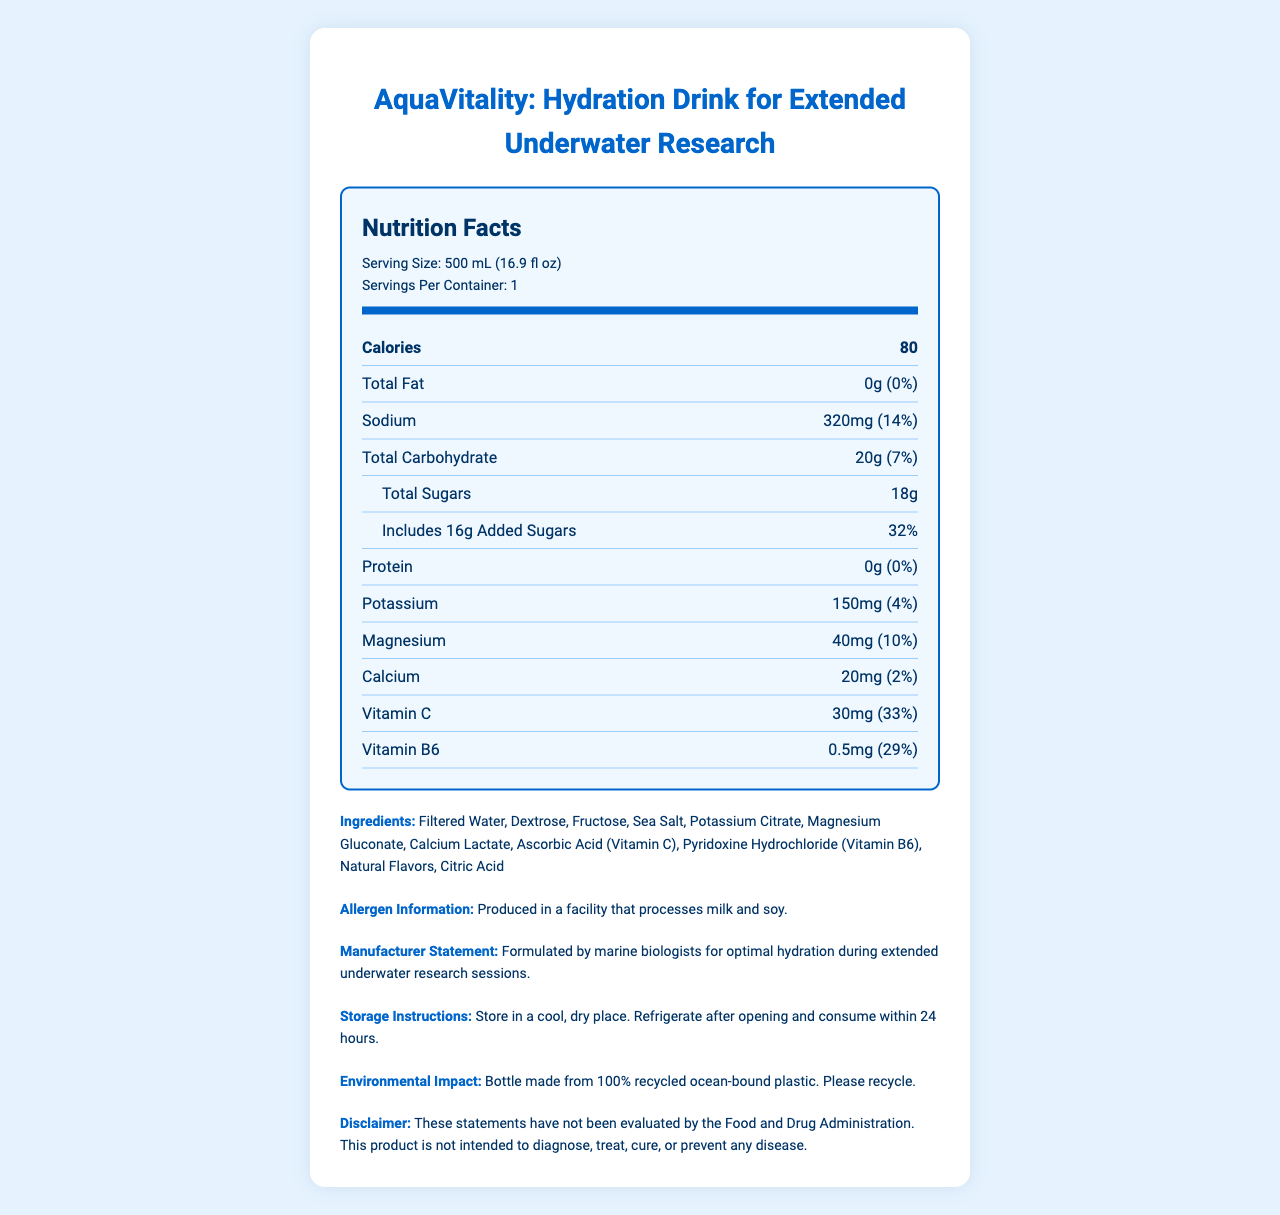what is the serving size of AquaVitality? According to the document, the serving size listed is 500 mL (16.9 fl oz).
Answer: 500 mL (16.9 fl oz) How much sodium is in one serving of AquaVitality? The document states that there are 320mg of sodium per serving.
Answer: 320mg What is the percentage of daily value for Calcium in AquaVitality? The document lists the calcium content as 20mg with a daily value of 2%.
Answer: 2% List three vitamins found in AquaVitality The document mentions Vitamin C, Vitamin B6, and Pyridoxine Hydrochloride (which is another name for Vitamin B6).
Answer: Vitamin C, Vitamin B6, Pyridoxine Hydrochloride Is there any protein in AquaVitality? The document states that there is 0g of protein in AquaVitality.
Answer: No Does AquaVitality contain any added sugars? The document mentions that there are 16g of added sugars in the total of 18g of sugars.
Answer: Yes What is the total carbohydrate content in AquaVitality? The document states that the total carbohydrate content is 20g which is 7% of the daily value.
Answer: 20g What percentage of the daily value of magnesium does AquaVitality provide? The document shows that AquaVitality contains 40mg of magnesium, which is 10% of the daily value.
Answer: 10% What is the brand statement for AquaVitality? This is directly stated in the Manufacturer Statement section of the document.
Answer: Formulated by marine biologists for optimal hydration during extended underwater research sessions. What should you do after opening AquaVitality? The storage instructions section advises to refrigerate after opening and consume within 24 hours.
Answer: Refrigerate and consume within 24 hours How many servings are there per container of AquaVitality? A. 1 B. 2 C. 4 D. 5 The document states that the servings per container is 1.
Answer: A How many calories does AquaVitality have per serving? A. 50 B. 60 C. 70 D. 80 The document specifies that AquaVitality contains 80 calories per serving.
Answer: D True or False: AquaVitality is produced in a facility that processes nuts. The allergen information indicates that the drink is produced in a facility that processes milk and soy, but there is no mention of nuts.
Answer: False Summarize the main goal and features of AquaVitality. This summary encapsulates the key aspects of AquaVitality as provided in the document, including its purpose, nutritional content, and environmental considerations.
Answer: AquaVitality is a hydration drink specifically formulated by marine biologists to support optimal hydration during extended underwater research sessions. It contains various essential nutrients, including sodium, potassium, magnesium, calcium, and vitamins C and B6, with a total of 80 calories per 500 mL serving. The drink is designed with recycled ocean-bound plastic and includes instructions for storage and consumption after opening. What type of plastic is used for the AquaVitality bottle? The document does not specify the type of plastic used, only that it is made from 100% recycled ocean-bound plastic.
Answer: Not enough information 